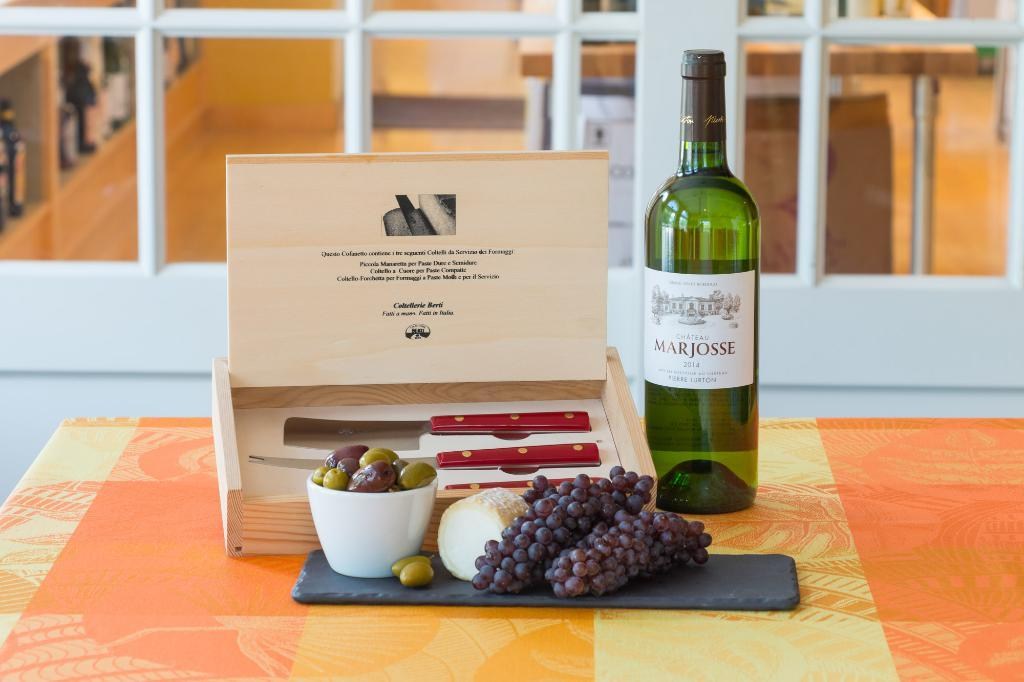Provide a one-sentence caption for the provided image. A wine bottle labeled Marjoss sits next to a box and grapes. 